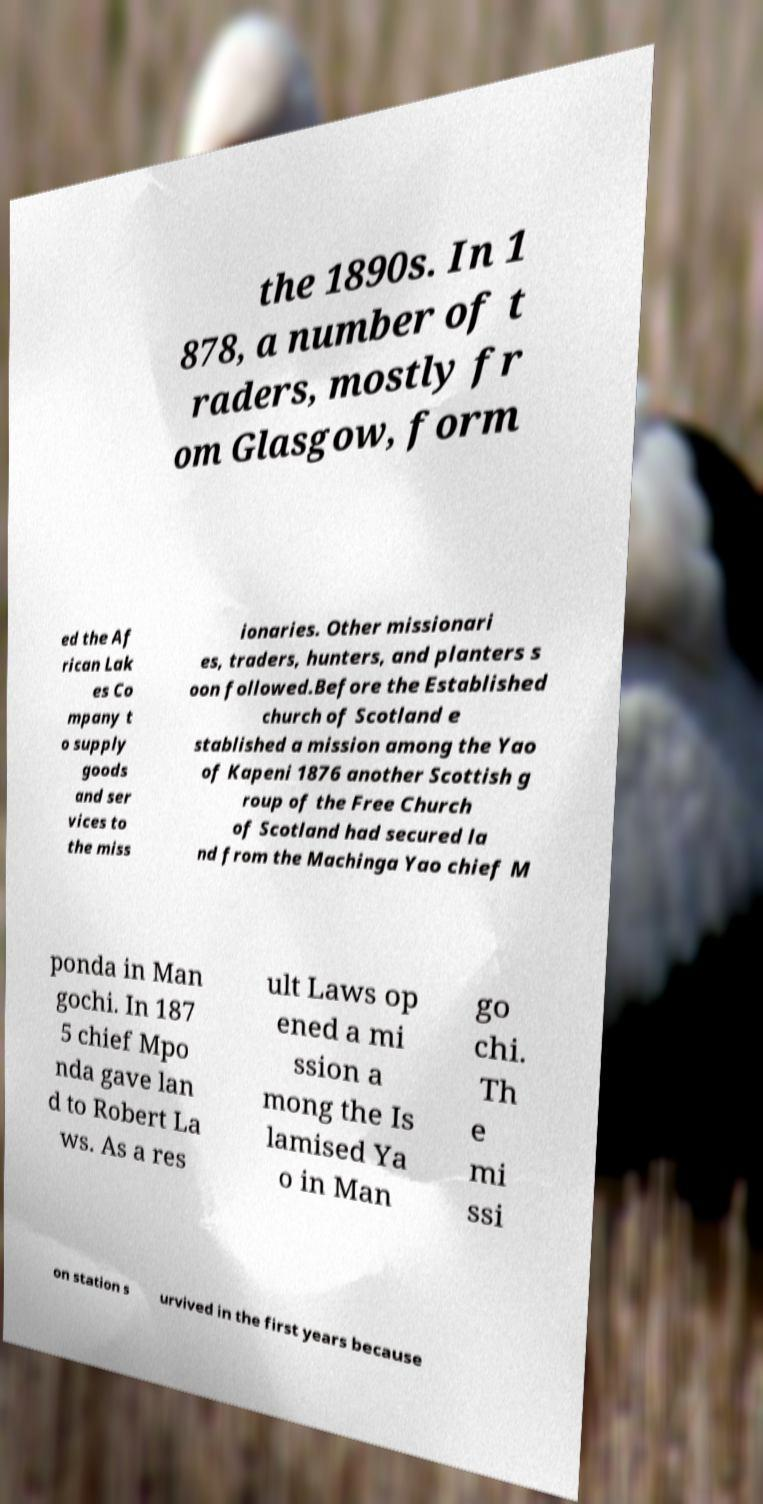What messages or text are displayed in this image? I need them in a readable, typed format. the 1890s. In 1 878, a number of t raders, mostly fr om Glasgow, form ed the Af rican Lak es Co mpany t o supply goods and ser vices to the miss ionaries. Other missionari es, traders, hunters, and planters s oon followed.Before the Established church of Scotland e stablished a mission among the Yao of Kapeni 1876 another Scottish g roup of the Free Church of Scotland had secured la nd from the Machinga Yao chief M ponda in Man gochi. In 187 5 chief Mpo nda gave lan d to Robert La ws. As a res ult Laws op ened a mi ssion a mong the Is lamised Ya o in Man go chi. Th e mi ssi on station s urvived in the first years because 